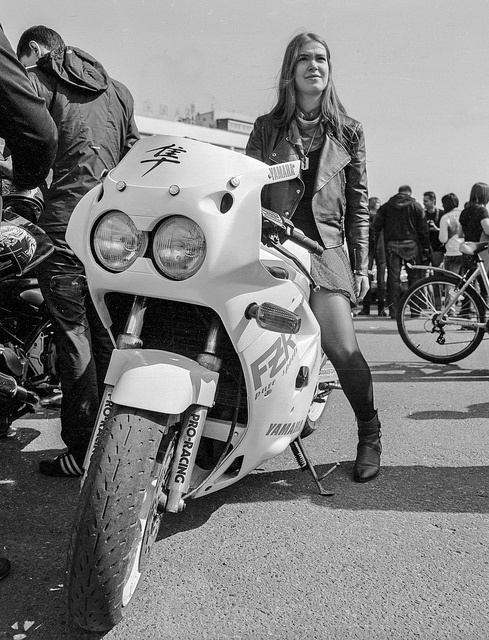Describe the objects in this image and their specific colors. I can see motorcycle in lightgray, darkgray, black, and gray tones, people in lightgray, black, and gray tones, people in lightgray, black, gray, and darkgray tones, motorcycle in lightgray, black, gray, and darkgray tones, and bicycle in lightgray, black, darkgray, and gray tones in this image. 